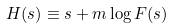Convert formula to latex. <formula><loc_0><loc_0><loc_500><loc_500>H ( s ) \equiv s + m \log F ( s )</formula> 